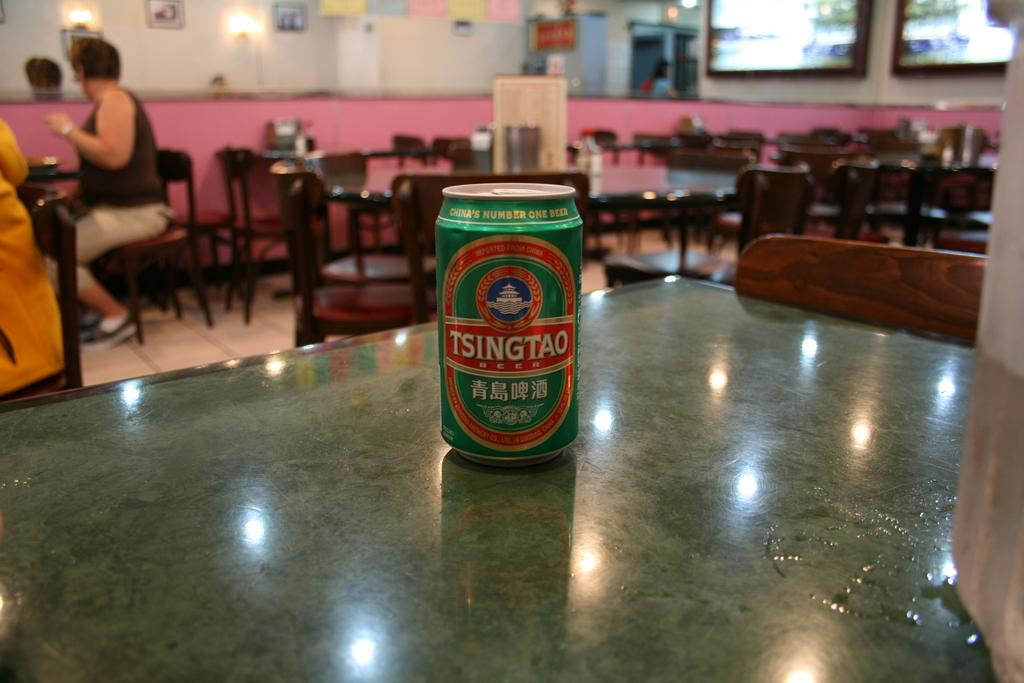<image>
Share a concise interpretation of the image provided. A can of Tsingtao sits on a table. 